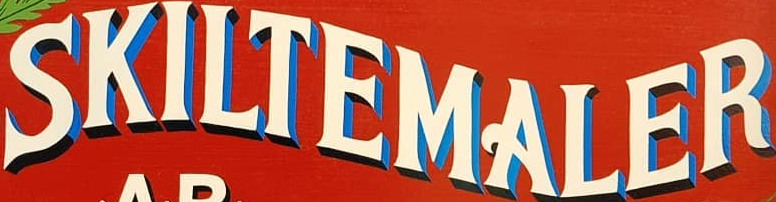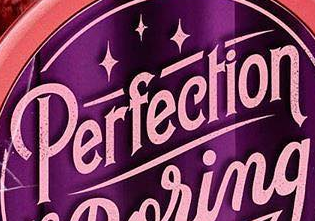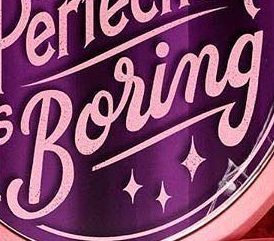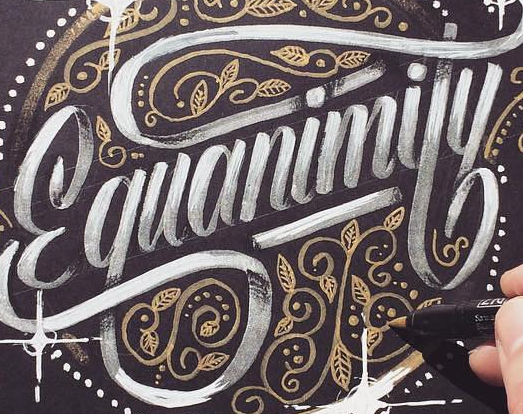Transcribe the words shown in these images in order, separated by a semicolon. SKILTEMALER; Perfection; Boring; Ɛquanimity 